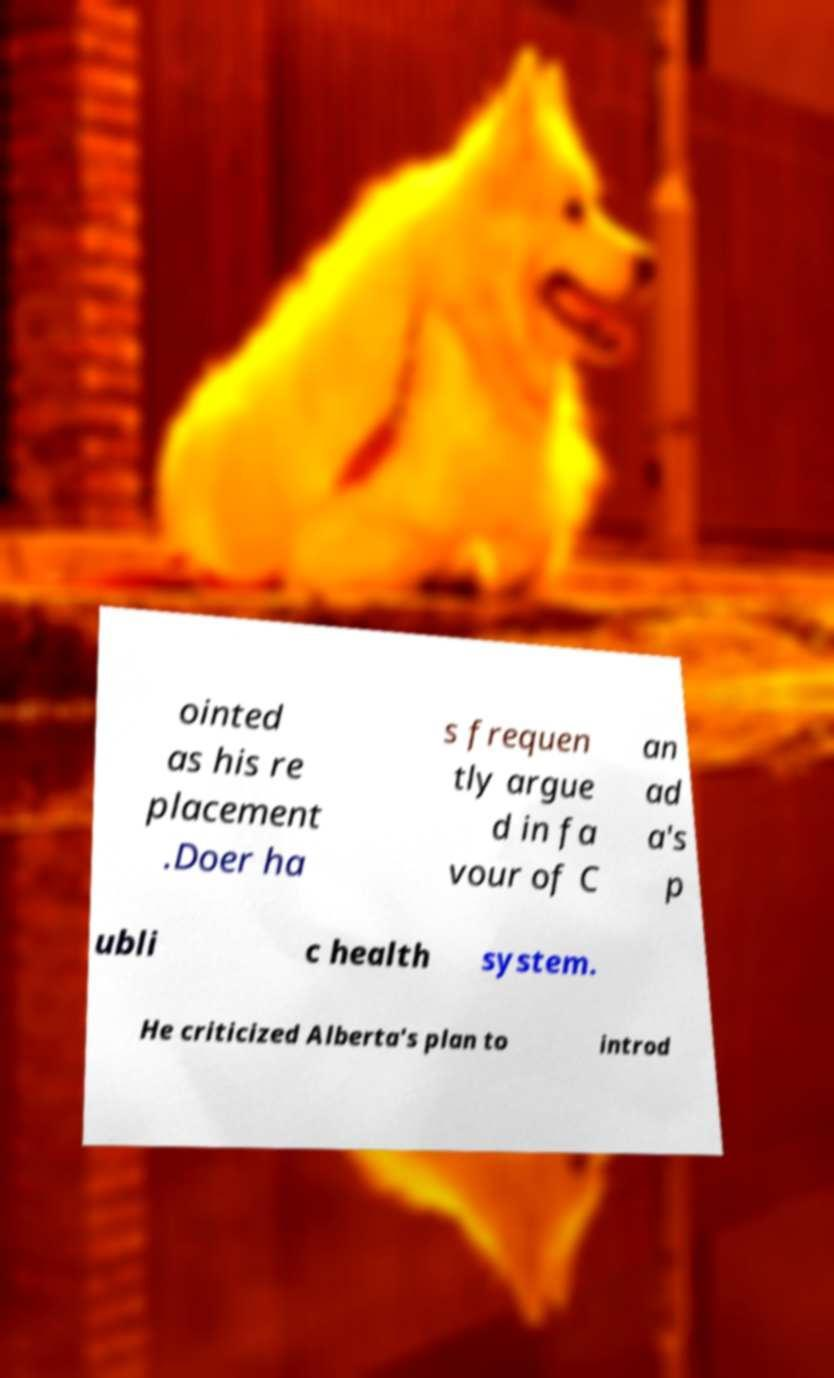I need the written content from this picture converted into text. Can you do that? ointed as his re placement .Doer ha s frequen tly argue d in fa vour of C an ad a's p ubli c health system. He criticized Alberta's plan to introd 